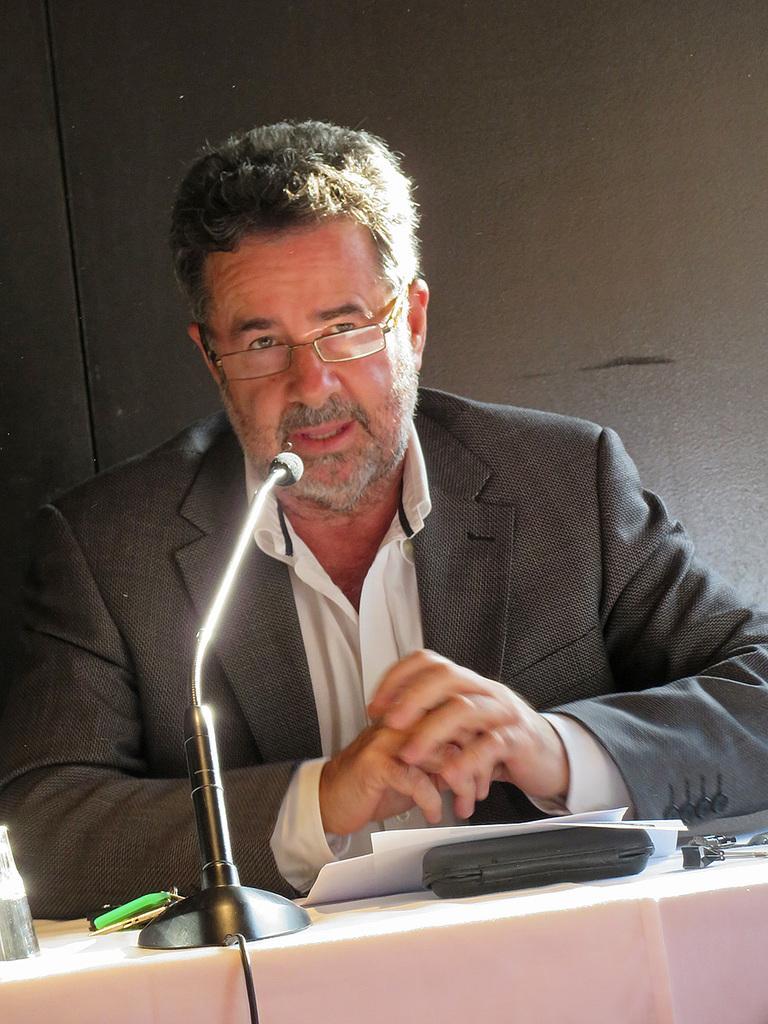Please provide a concise description of this image. In this picture we can see a person. There is a micro phone, papers, box and other objects visible in the background. 